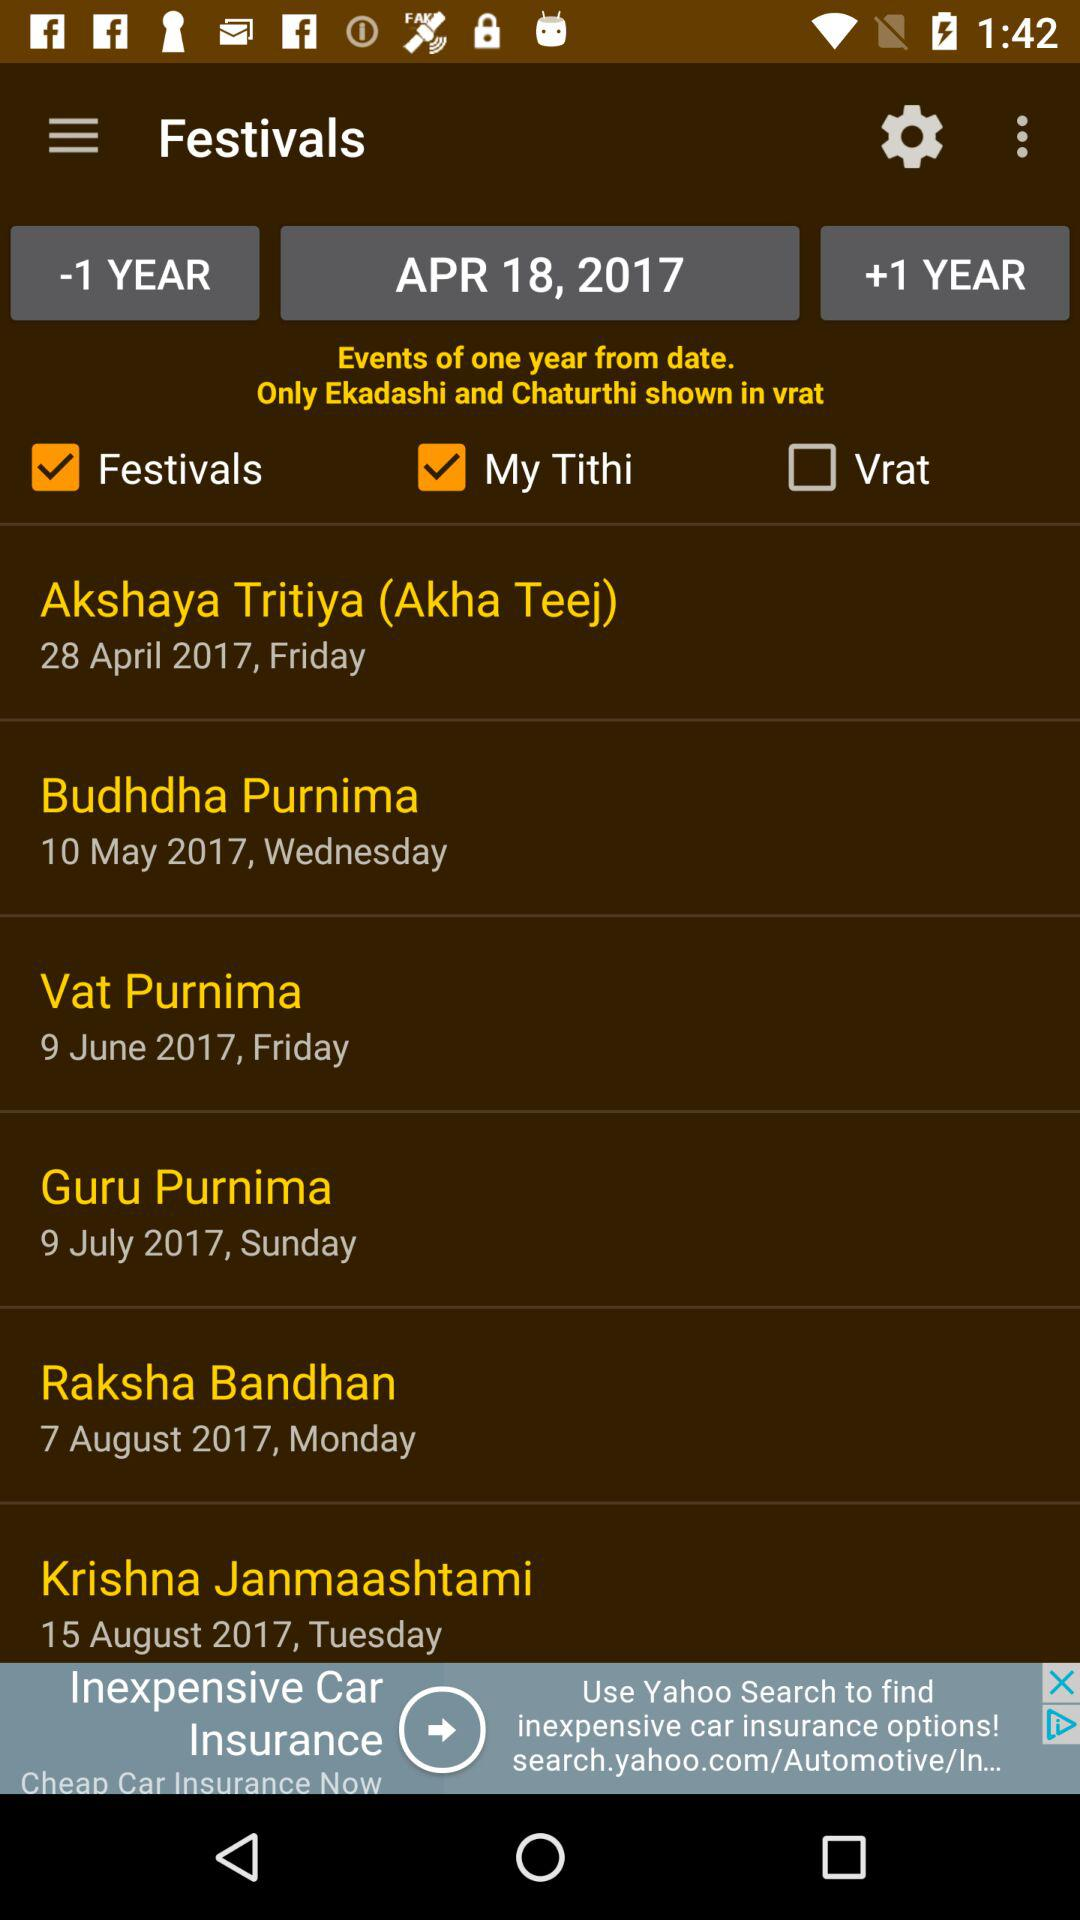Which festival is on 7 August 2017? The festival on August 7, 2017 is "Raksha Bandhan". 